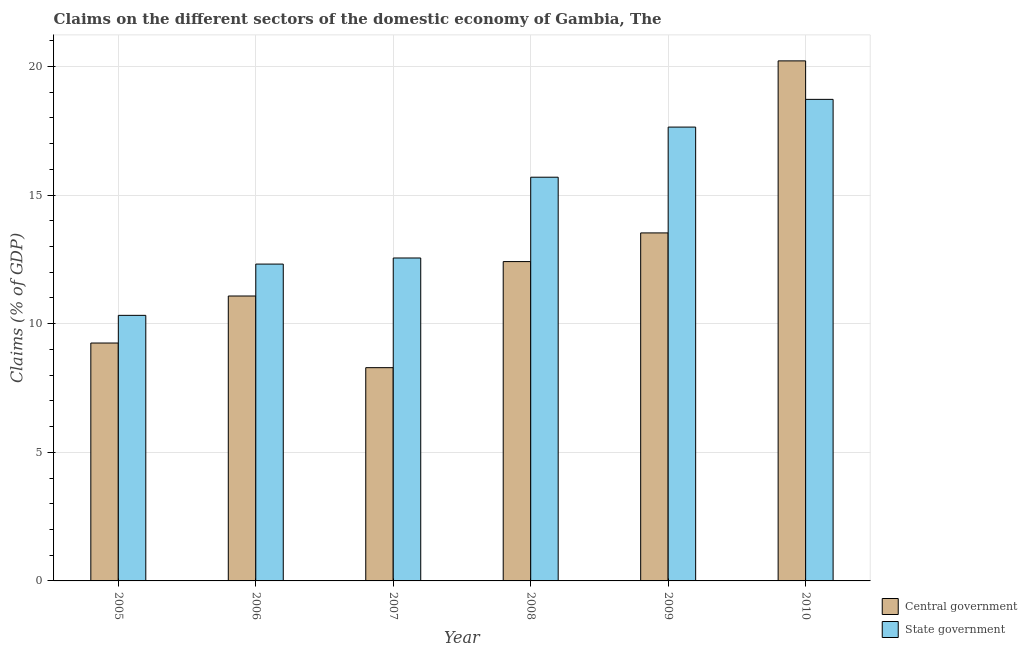How many different coloured bars are there?
Give a very brief answer. 2. How many groups of bars are there?
Offer a very short reply. 6. Are the number of bars on each tick of the X-axis equal?
Your answer should be compact. Yes. How many bars are there on the 4th tick from the left?
Your answer should be compact. 2. In how many cases, is the number of bars for a given year not equal to the number of legend labels?
Make the answer very short. 0. What is the claims on state government in 2006?
Provide a short and direct response. 12.32. Across all years, what is the maximum claims on central government?
Provide a succinct answer. 20.22. Across all years, what is the minimum claims on central government?
Provide a short and direct response. 8.29. In which year was the claims on state government maximum?
Your response must be concise. 2010. In which year was the claims on central government minimum?
Provide a short and direct response. 2007. What is the total claims on central government in the graph?
Ensure brevity in your answer.  74.78. What is the difference between the claims on state government in 2009 and that in 2010?
Your answer should be very brief. -1.08. What is the difference between the claims on central government in 2009 and the claims on state government in 2010?
Your answer should be very brief. -6.69. What is the average claims on central government per year?
Offer a terse response. 12.46. In how many years, is the claims on central government greater than 6 %?
Offer a very short reply. 6. What is the ratio of the claims on state government in 2005 to that in 2007?
Your answer should be compact. 0.82. What is the difference between the highest and the second highest claims on state government?
Offer a terse response. 1.08. What is the difference between the highest and the lowest claims on state government?
Ensure brevity in your answer.  8.4. In how many years, is the claims on central government greater than the average claims on central government taken over all years?
Your answer should be very brief. 2. Is the sum of the claims on central government in 2005 and 2007 greater than the maximum claims on state government across all years?
Make the answer very short. No. What does the 2nd bar from the left in 2009 represents?
Make the answer very short. State government. What does the 2nd bar from the right in 2010 represents?
Provide a succinct answer. Central government. How many years are there in the graph?
Ensure brevity in your answer.  6. Are the values on the major ticks of Y-axis written in scientific E-notation?
Make the answer very short. No. Does the graph contain grids?
Your response must be concise. Yes. Where does the legend appear in the graph?
Offer a terse response. Bottom right. How are the legend labels stacked?
Offer a very short reply. Vertical. What is the title of the graph?
Ensure brevity in your answer.  Claims on the different sectors of the domestic economy of Gambia, The. What is the label or title of the X-axis?
Provide a succinct answer. Year. What is the label or title of the Y-axis?
Your response must be concise. Claims (% of GDP). What is the Claims (% of GDP) of Central government in 2005?
Offer a very short reply. 9.25. What is the Claims (% of GDP) in State government in 2005?
Offer a very short reply. 10.32. What is the Claims (% of GDP) in Central government in 2006?
Give a very brief answer. 11.08. What is the Claims (% of GDP) in State government in 2006?
Make the answer very short. 12.32. What is the Claims (% of GDP) of Central government in 2007?
Your answer should be very brief. 8.29. What is the Claims (% of GDP) in State government in 2007?
Keep it short and to the point. 12.55. What is the Claims (% of GDP) of Central government in 2008?
Provide a short and direct response. 12.41. What is the Claims (% of GDP) in State government in 2008?
Your answer should be very brief. 15.7. What is the Claims (% of GDP) of Central government in 2009?
Make the answer very short. 13.53. What is the Claims (% of GDP) of State government in 2009?
Give a very brief answer. 17.64. What is the Claims (% of GDP) in Central government in 2010?
Your response must be concise. 20.22. What is the Claims (% of GDP) in State government in 2010?
Give a very brief answer. 18.72. Across all years, what is the maximum Claims (% of GDP) in Central government?
Ensure brevity in your answer.  20.22. Across all years, what is the maximum Claims (% of GDP) in State government?
Make the answer very short. 18.72. Across all years, what is the minimum Claims (% of GDP) of Central government?
Your answer should be very brief. 8.29. Across all years, what is the minimum Claims (% of GDP) of State government?
Keep it short and to the point. 10.32. What is the total Claims (% of GDP) in Central government in the graph?
Your response must be concise. 74.78. What is the total Claims (% of GDP) in State government in the graph?
Offer a very short reply. 87.26. What is the difference between the Claims (% of GDP) of Central government in 2005 and that in 2006?
Your answer should be compact. -1.83. What is the difference between the Claims (% of GDP) of State government in 2005 and that in 2006?
Make the answer very short. -1.99. What is the difference between the Claims (% of GDP) of Central government in 2005 and that in 2007?
Provide a short and direct response. 0.96. What is the difference between the Claims (% of GDP) of State government in 2005 and that in 2007?
Your answer should be very brief. -2.23. What is the difference between the Claims (% of GDP) of Central government in 2005 and that in 2008?
Ensure brevity in your answer.  -3.17. What is the difference between the Claims (% of GDP) of State government in 2005 and that in 2008?
Make the answer very short. -5.37. What is the difference between the Claims (% of GDP) in Central government in 2005 and that in 2009?
Make the answer very short. -4.28. What is the difference between the Claims (% of GDP) of State government in 2005 and that in 2009?
Keep it short and to the point. -7.32. What is the difference between the Claims (% of GDP) of Central government in 2005 and that in 2010?
Offer a terse response. -10.97. What is the difference between the Claims (% of GDP) in State government in 2005 and that in 2010?
Offer a terse response. -8.4. What is the difference between the Claims (% of GDP) in Central government in 2006 and that in 2007?
Provide a short and direct response. 2.79. What is the difference between the Claims (% of GDP) in State government in 2006 and that in 2007?
Offer a very short reply. -0.24. What is the difference between the Claims (% of GDP) in Central government in 2006 and that in 2008?
Your answer should be very brief. -1.34. What is the difference between the Claims (% of GDP) of State government in 2006 and that in 2008?
Your answer should be compact. -3.38. What is the difference between the Claims (% of GDP) of Central government in 2006 and that in 2009?
Make the answer very short. -2.45. What is the difference between the Claims (% of GDP) of State government in 2006 and that in 2009?
Offer a terse response. -5.33. What is the difference between the Claims (% of GDP) in Central government in 2006 and that in 2010?
Your response must be concise. -9.14. What is the difference between the Claims (% of GDP) in State government in 2006 and that in 2010?
Your answer should be very brief. -6.4. What is the difference between the Claims (% of GDP) in Central government in 2007 and that in 2008?
Give a very brief answer. -4.12. What is the difference between the Claims (% of GDP) in State government in 2007 and that in 2008?
Provide a succinct answer. -3.14. What is the difference between the Claims (% of GDP) in Central government in 2007 and that in 2009?
Ensure brevity in your answer.  -5.24. What is the difference between the Claims (% of GDP) of State government in 2007 and that in 2009?
Provide a short and direct response. -5.09. What is the difference between the Claims (% of GDP) in Central government in 2007 and that in 2010?
Your response must be concise. -11.93. What is the difference between the Claims (% of GDP) of State government in 2007 and that in 2010?
Offer a very short reply. -6.17. What is the difference between the Claims (% of GDP) of Central government in 2008 and that in 2009?
Make the answer very short. -1.11. What is the difference between the Claims (% of GDP) of State government in 2008 and that in 2009?
Your answer should be very brief. -1.95. What is the difference between the Claims (% of GDP) in Central government in 2008 and that in 2010?
Your response must be concise. -7.8. What is the difference between the Claims (% of GDP) in State government in 2008 and that in 2010?
Keep it short and to the point. -3.03. What is the difference between the Claims (% of GDP) in Central government in 2009 and that in 2010?
Provide a short and direct response. -6.69. What is the difference between the Claims (% of GDP) in State government in 2009 and that in 2010?
Give a very brief answer. -1.08. What is the difference between the Claims (% of GDP) of Central government in 2005 and the Claims (% of GDP) of State government in 2006?
Your answer should be very brief. -3.07. What is the difference between the Claims (% of GDP) in Central government in 2005 and the Claims (% of GDP) in State government in 2007?
Provide a succinct answer. -3.31. What is the difference between the Claims (% of GDP) of Central government in 2005 and the Claims (% of GDP) of State government in 2008?
Provide a succinct answer. -6.45. What is the difference between the Claims (% of GDP) of Central government in 2005 and the Claims (% of GDP) of State government in 2009?
Offer a terse response. -8.39. What is the difference between the Claims (% of GDP) in Central government in 2005 and the Claims (% of GDP) in State government in 2010?
Provide a succinct answer. -9.47. What is the difference between the Claims (% of GDP) of Central government in 2006 and the Claims (% of GDP) of State government in 2007?
Provide a succinct answer. -1.48. What is the difference between the Claims (% of GDP) in Central government in 2006 and the Claims (% of GDP) in State government in 2008?
Your answer should be very brief. -4.62. What is the difference between the Claims (% of GDP) of Central government in 2006 and the Claims (% of GDP) of State government in 2009?
Your answer should be compact. -6.57. What is the difference between the Claims (% of GDP) in Central government in 2006 and the Claims (% of GDP) in State government in 2010?
Provide a succinct answer. -7.64. What is the difference between the Claims (% of GDP) of Central government in 2007 and the Claims (% of GDP) of State government in 2008?
Offer a very short reply. -7.4. What is the difference between the Claims (% of GDP) of Central government in 2007 and the Claims (% of GDP) of State government in 2009?
Make the answer very short. -9.35. What is the difference between the Claims (% of GDP) in Central government in 2007 and the Claims (% of GDP) in State government in 2010?
Make the answer very short. -10.43. What is the difference between the Claims (% of GDP) of Central government in 2008 and the Claims (% of GDP) of State government in 2009?
Your response must be concise. -5.23. What is the difference between the Claims (% of GDP) of Central government in 2008 and the Claims (% of GDP) of State government in 2010?
Provide a succinct answer. -6.31. What is the difference between the Claims (% of GDP) of Central government in 2009 and the Claims (% of GDP) of State government in 2010?
Offer a terse response. -5.19. What is the average Claims (% of GDP) in Central government per year?
Ensure brevity in your answer.  12.46. What is the average Claims (% of GDP) in State government per year?
Your answer should be compact. 14.54. In the year 2005, what is the difference between the Claims (% of GDP) in Central government and Claims (% of GDP) in State government?
Provide a short and direct response. -1.08. In the year 2006, what is the difference between the Claims (% of GDP) in Central government and Claims (% of GDP) in State government?
Your answer should be compact. -1.24. In the year 2007, what is the difference between the Claims (% of GDP) of Central government and Claims (% of GDP) of State government?
Give a very brief answer. -4.26. In the year 2008, what is the difference between the Claims (% of GDP) in Central government and Claims (% of GDP) in State government?
Your answer should be compact. -3.28. In the year 2009, what is the difference between the Claims (% of GDP) of Central government and Claims (% of GDP) of State government?
Ensure brevity in your answer.  -4.11. In the year 2010, what is the difference between the Claims (% of GDP) in Central government and Claims (% of GDP) in State government?
Your answer should be compact. 1.5. What is the ratio of the Claims (% of GDP) of Central government in 2005 to that in 2006?
Provide a succinct answer. 0.83. What is the ratio of the Claims (% of GDP) of State government in 2005 to that in 2006?
Your answer should be compact. 0.84. What is the ratio of the Claims (% of GDP) in Central government in 2005 to that in 2007?
Your response must be concise. 1.12. What is the ratio of the Claims (% of GDP) in State government in 2005 to that in 2007?
Offer a terse response. 0.82. What is the ratio of the Claims (% of GDP) in Central government in 2005 to that in 2008?
Your answer should be very brief. 0.74. What is the ratio of the Claims (% of GDP) in State government in 2005 to that in 2008?
Ensure brevity in your answer.  0.66. What is the ratio of the Claims (% of GDP) of Central government in 2005 to that in 2009?
Ensure brevity in your answer.  0.68. What is the ratio of the Claims (% of GDP) in State government in 2005 to that in 2009?
Make the answer very short. 0.59. What is the ratio of the Claims (% of GDP) of Central government in 2005 to that in 2010?
Provide a succinct answer. 0.46. What is the ratio of the Claims (% of GDP) in State government in 2005 to that in 2010?
Make the answer very short. 0.55. What is the ratio of the Claims (% of GDP) in Central government in 2006 to that in 2007?
Keep it short and to the point. 1.34. What is the ratio of the Claims (% of GDP) of State government in 2006 to that in 2007?
Keep it short and to the point. 0.98. What is the ratio of the Claims (% of GDP) in Central government in 2006 to that in 2008?
Make the answer very short. 0.89. What is the ratio of the Claims (% of GDP) of State government in 2006 to that in 2008?
Make the answer very short. 0.78. What is the ratio of the Claims (% of GDP) in Central government in 2006 to that in 2009?
Provide a short and direct response. 0.82. What is the ratio of the Claims (% of GDP) of State government in 2006 to that in 2009?
Your answer should be compact. 0.7. What is the ratio of the Claims (% of GDP) of Central government in 2006 to that in 2010?
Offer a terse response. 0.55. What is the ratio of the Claims (% of GDP) of State government in 2006 to that in 2010?
Offer a very short reply. 0.66. What is the ratio of the Claims (% of GDP) in Central government in 2007 to that in 2008?
Offer a very short reply. 0.67. What is the ratio of the Claims (% of GDP) in State government in 2007 to that in 2008?
Provide a short and direct response. 0.8. What is the ratio of the Claims (% of GDP) in Central government in 2007 to that in 2009?
Provide a succinct answer. 0.61. What is the ratio of the Claims (% of GDP) of State government in 2007 to that in 2009?
Provide a short and direct response. 0.71. What is the ratio of the Claims (% of GDP) in Central government in 2007 to that in 2010?
Your answer should be compact. 0.41. What is the ratio of the Claims (% of GDP) of State government in 2007 to that in 2010?
Provide a short and direct response. 0.67. What is the ratio of the Claims (% of GDP) of Central government in 2008 to that in 2009?
Provide a short and direct response. 0.92. What is the ratio of the Claims (% of GDP) of State government in 2008 to that in 2009?
Offer a very short reply. 0.89. What is the ratio of the Claims (% of GDP) in Central government in 2008 to that in 2010?
Your answer should be very brief. 0.61. What is the ratio of the Claims (% of GDP) in State government in 2008 to that in 2010?
Your answer should be compact. 0.84. What is the ratio of the Claims (% of GDP) of Central government in 2009 to that in 2010?
Keep it short and to the point. 0.67. What is the ratio of the Claims (% of GDP) in State government in 2009 to that in 2010?
Ensure brevity in your answer.  0.94. What is the difference between the highest and the second highest Claims (% of GDP) in Central government?
Offer a terse response. 6.69. What is the difference between the highest and the second highest Claims (% of GDP) of State government?
Your response must be concise. 1.08. What is the difference between the highest and the lowest Claims (% of GDP) of Central government?
Give a very brief answer. 11.93. What is the difference between the highest and the lowest Claims (% of GDP) of State government?
Offer a terse response. 8.4. 